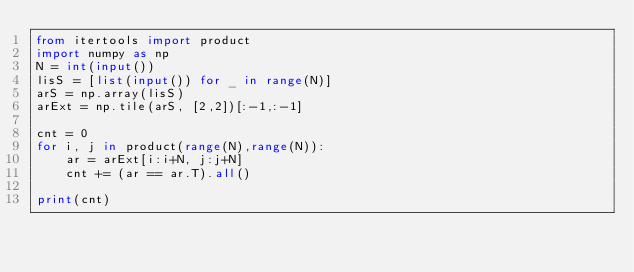<code> <loc_0><loc_0><loc_500><loc_500><_Python_>from itertools import product
import numpy as np
N = int(input())
lisS = [list(input()) for _ in range(N)]
arS = np.array(lisS)
arExt = np.tile(arS, [2,2])[:-1,:-1]

cnt = 0
for i, j in product(range(N),range(N)):
    ar = arExt[i:i+N, j:j+N]
    cnt += (ar == ar.T).all()

print(cnt)

</code> 